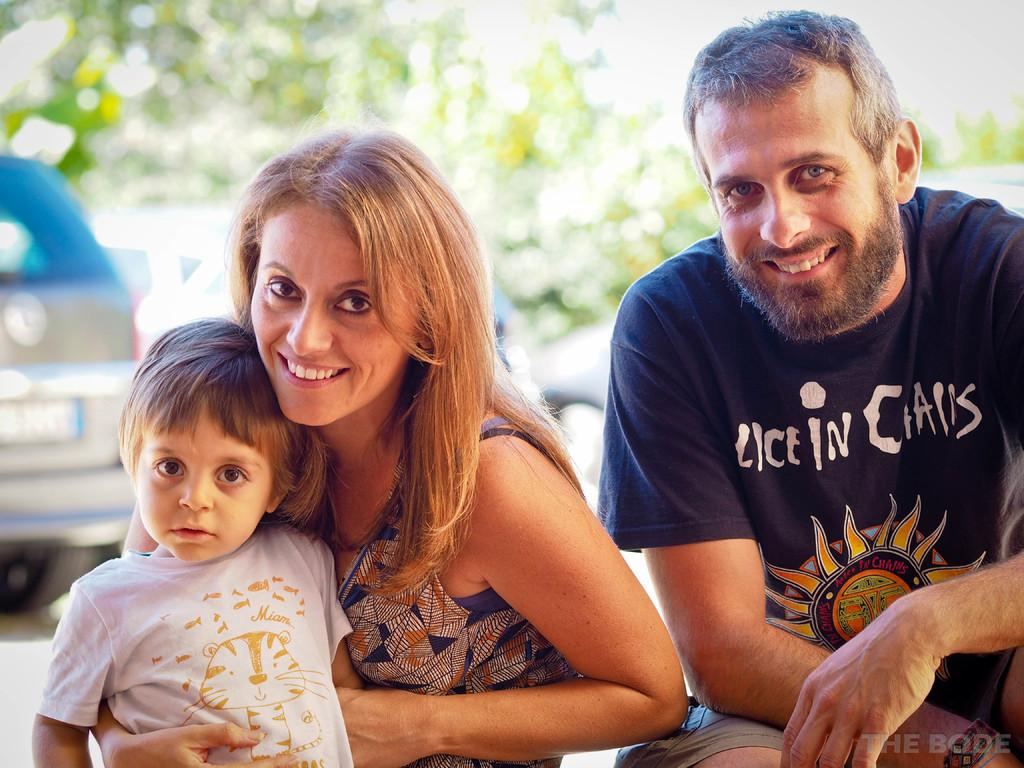Who or what can be seen in the front of the image? There are persons in the front of the image. What is the facial expression of the persons in the image? The persons are smiling. What can be seen in the background of the image? There are cars and trees in the background of the image. What type of screw can be seen holding the celery together in the image? There is no screw or celery present in the image. What material is the plastic used for in the image? There is no plastic present in the image. 